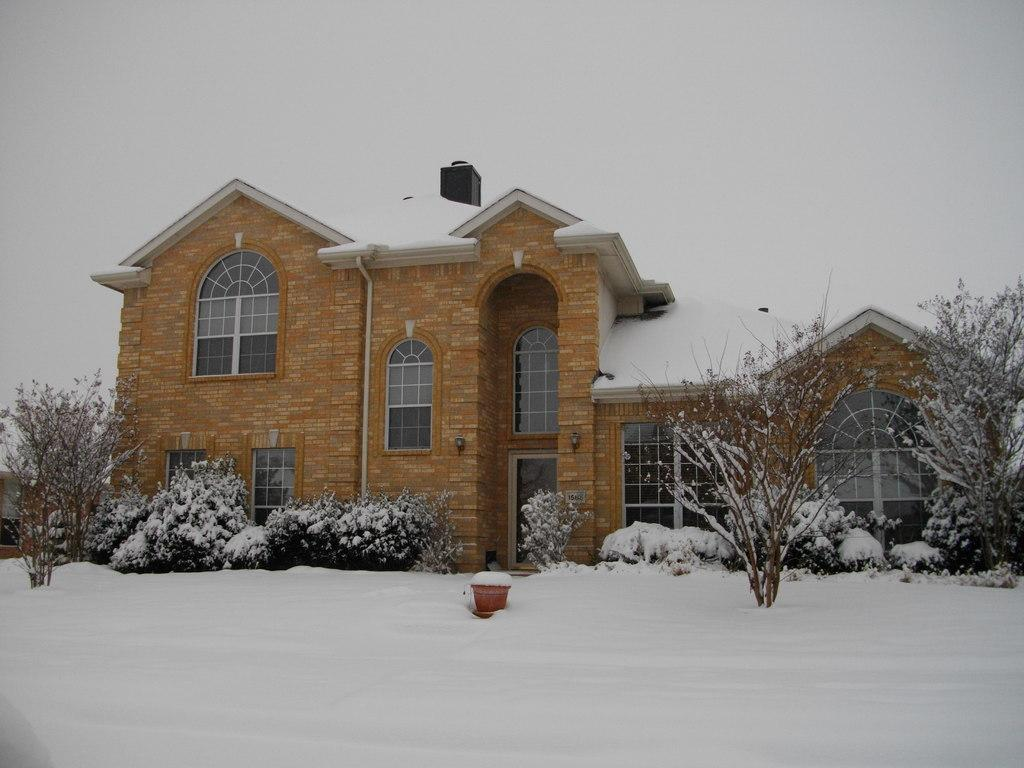Where was the image taken? The image was clicked outside. What is the main subject in the middle of the image? There is a building in the middle of the image. What other natural elements can be seen in the middle of the image? There are bushes and trees in the middle of the image. What is visible at the top of the image? The sky is visible at the top of the image. What is the unusual feature at the bottom of the image? There is ice at the bottom of the image. What type of ray is swimming in the ice at the bottom of the image? There are no rays present in the image; it features a building, bushes, trees, and ice. What color stocking is the manager wearing in the image? There is no manager or stocking present in the image. 